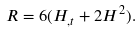<formula> <loc_0><loc_0><loc_500><loc_500>R = 6 ( H _ { , t } + 2 H ^ { 2 } ) .</formula> 